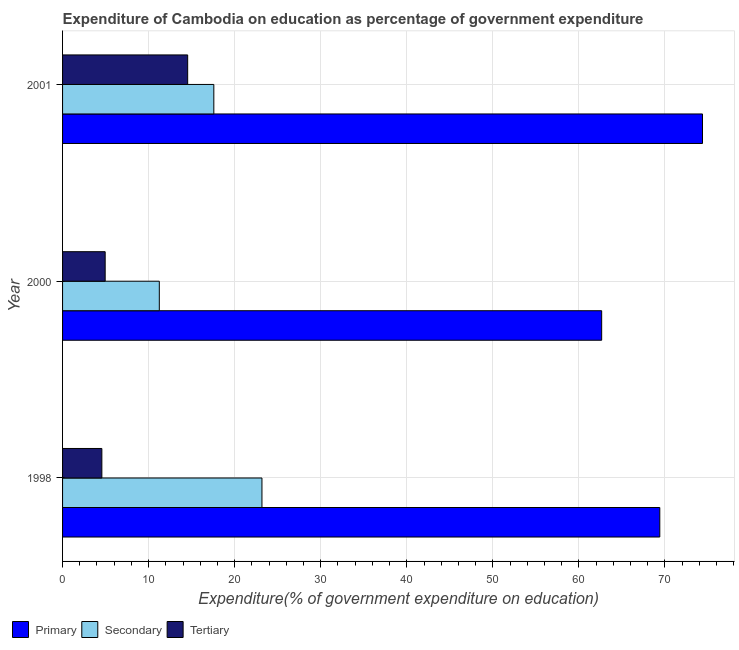Are the number of bars per tick equal to the number of legend labels?
Your answer should be compact. Yes. Are the number of bars on each tick of the Y-axis equal?
Offer a very short reply. Yes. How many bars are there on the 1st tick from the bottom?
Provide a succinct answer. 3. What is the label of the 3rd group of bars from the top?
Offer a very short reply. 1998. In how many cases, is the number of bars for a given year not equal to the number of legend labels?
Your answer should be compact. 0. What is the expenditure on primary education in 1998?
Ensure brevity in your answer.  69.4. Across all years, what is the maximum expenditure on primary education?
Your answer should be compact. 74.36. Across all years, what is the minimum expenditure on tertiary education?
Give a very brief answer. 4.57. What is the total expenditure on secondary education in the graph?
Your answer should be very brief. 51.99. What is the difference between the expenditure on secondary education in 1998 and that in 2001?
Make the answer very short. 5.59. What is the difference between the expenditure on primary education in 2000 and the expenditure on secondary education in 1998?
Your answer should be compact. 39.48. What is the average expenditure on primary education per year?
Provide a succinct answer. 68.8. In the year 2000, what is the difference between the expenditure on tertiary education and expenditure on secondary education?
Your answer should be compact. -6.29. What is the ratio of the expenditure on primary education in 1998 to that in 2001?
Ensure brevity in your answer.  0.93. Is the expenditure on primary education in 1998 less than that in 2000?
Your answer should be compact. No. What is the difference between the highest and the second highest expenditure on primary education?
Provide a short and direct response. 4.96. What is the difference between the highest and the lowest expenditure on primary education?
Provide a short and direct response. 11.72. In how many years, is the expenditure on primary education greater than the average expenditure on primary education taken over all years?
Ensure brevity in your answer.  2. What does the 3rd bar from the top in 2001 represents?
Offer a terse response. Primary. What does the 1st bar from the bottom in 2000 represents?
Provide a short and direct response. Primary. How many bars are there?
Provide a succinct answer. 9. Does the graph contain any zero values?
Your response must be concise. No. Does the graph contain grids?
Ensure brevity in your answer.  Yes. How many legend labels are there?
Your answer should be compact. 3. What is the title of the graph?
Keep it short and to the point. Expenditure of Cambodia on education as percentage of government expenditure. Does "Czech Republic" appear as one of the legend labels in the graph?
Offer a terse response. No. What is the label or title of the X-axis?
Ensure brevity in your answer.  Expenditure(% of government expenditure on education). What is the Expenditure(% of government expenditure on education) in Primary in 1998?
Your answer should be very brief. 69.4. What is the Expenditure(% of government expenditure on education) in Secondary in 1998?
Your answer should be compact. 23.17. What is the Expenditure(% of government expenditure on education) in Tertiary in 1998?
Make the answer very short. 4.57. What is the Expenditure(% of government expenditure on education) in Primary in 2000?
Ensure brevity in your answer.  62.65. What is the Expenditure(% of government expenditure on education) of Secondary in 2000?
Your response must be concise. 11.24. What is the Expenditure(% of government expenditure on education) in Tertiary in 2000?
Ensure brevity in your answer.  4.95. What is the Expenditure(% of government expenditure on education) of Primary in 2001?
Ensure brevity in your answer.  74.36. What is the Expenditure(% of government expenditure on education) in Secondary in 2001?
Make the answer very short. 17.58. What is the Expenditure(% of government expenditure on education) in Tertiary in 2001?
Offer a terse response. 14.54. Across all years, what is the maximum Expenditure(% of government expenditure on education) in Primary?
Provide a succinct answer. 74.36. Across all years, what is the maximum Expenditure(% of government expenditure on education) of Secondary?
Your answer should be compact. 23.17. Across all years, what is the maximum Expenditure(% of government expenditure on education) of Tertiary?
Your answer should be compact. 14.54. Across all years, what is the minimum Expenditure(% of government expenditure on education) of Primary?
Ensure brevity in your answer.  62.65. Across all years, what is the minimum Expenditure(% of government expenditure on education) in Secondary?
Offer a terse response. 11.24. Across all years, what is the minimum Expenditure(% of government expenditure on education) in Tertiary?
Ensure brevity in your answer.  4.57. What is the total Expenditure(% of government expenditure on education) in Primary in the graph?
Keep it short and to the point. 206.41. What is the total Expenditure(% of government expenditure on education) of Secondary in the graph?
Offer a very short reply. 51.99. What is the total Expenditure(% of government expenditure on education) of Tertiary in the graph?
Provide a succinct answer. 24.05. What is the difference between the Expenditure(% of government expenditure on education) in Primary in 1998 and that in 2000?
Provide a short and direct response. 6.76. What is the difference between the Expenditure(% of government expenditure on education) in Secondary in 1998 and that in 2000?
Offer a terse response. 11.93. What is the difference between the Expenditure(% of government expenditure on education) of Tertiary in 1998 and that in 2000?
Your response must be concise. -0.39. What is the difference between the Expenditure(% of government expenditure on education) in Primary in 1998 and that in 2001?
Provide a short and direct response. -4.96. What is the difference between the Expenditure(% of government expenditure on education) in Secondary in 1998 and that in 2001?
Offer a terse response. 5.59. What is the difference between the Expenditure(% of government expenditure on education) in Tertiary in 1998 and that in 2001?
Your answer should be very brief. -9.97. What is the difference between the Expenditure(% of government expenditure on education) of Primary in 2000 and that in 2001?
Provide a short and direct response. -11.72. What is the difference between the Expenditure(% of government expenditure on education) in Secondary in 2000 and that in 2001?
Offer a very short reply. -6.34. What is the difference between the Expenditure(% of government expenditure on education) in Tertiary in 2000 and that in 2001?
Offer a very short reply. -9.59. What is the difference between the Expenditure(% of government expenditure on education) of Primary in 1998 and the Expenditure(% of government expenditure on education) of Secondary in 2000?
Your answer should be very brief. 58.16. What is the difference between the Expenditure(% of government expenditure on education) of Primary in 1998 and the Expenditure(% of government expenditure on education) of Tertiary in 2000?
Make the answer very short. 64.45. What is the difference between the Expenditure(% of government expenditure on education) in Secondary in 1998 and the Expenditure(% of government expenditure on education) in Tertiary in 2000?
Offer a very short reply. 18.22. What is the difference between the Expenditure(% of government expenditure on education) in Primary in 1998 and the Expenditure(% of government expenditure on education) in Secondary in 2001?
Provide a succinct answer. 51.82. What is the difference between the Expenditure(% of government expenditure on education) in Primary in 1998 and the Expenditure(% of government expenditure on education) in Tertiary in 2001?
Make the answer very short. 54.86. What is the difference between the Expenditure(% of government expenditure on education) of Secondary in 1998 and the Expenditure(% of government expenditure on education) of Tertiary in 2001?
Offer a very short reply. 8.63. What is the difference between the Expenditure(% of government expenditure on education) of Primary in 2000 and the Expenditure(% of government expenditure on education) of Secondary in 2001?
Give a very brief answer. 45.07. What is the difference between the Expenditure(% of government expenditure on education) in Primary in 2000 and the Expenditure(% of government expenditure on education) in Tertiary in 2001?
Keep it short and to the point. 48.11. What is the difference between the Expenditure(% of government expenditure on education) of Secondary in 2000 and the Expenditure(% of government expenditure on education) of Tertiary in 2001?
Give a very brief answer. -3.29. What is the average Expenditure(% of government expenditure on education) in Primary per year?
Your response must be concise. 68.8. What is the average Expenditure(% of government expenditure on education) of Secondary per year?
Your response must be concise. 17.33. What is the average Expenditure(% of government expenditure on education) of Tertiary per year?
Offer a very short reply. 8.02. In the year 1998, what is the difference between the Expenditure(% of government expenditure on education) in Primary and Expenditure(% of government expenditure on education) in Secondary?
Provide a short and direct response. 46.23. In the year 1998, what is the difference between the Expenditure(% of government expenditure on education) of Primary and Expenditure(% of government expenditure on education) of Tertiary?
Ensure brevity in your answer.  64.84. In the year 1998, what is the difference between the Expenditure(% of government expenditure on education) in Secondary and Expenditure(% of government expenditure on education) in Tertiary?
Keep it short and to the point. 18.6. In the year 2000, what is the difference between the Expenditure(% of government expenditure on education) of Primary and Expenditure(% of government expenditure on education) of Secondary?
Offer a very short reply. 51.4. In the year 2000, what is the difference between the Expenditure(% of government expenditure on education) in Primary and Expenditure(% of government expenditure on education) in Tertiary?
Your answer should be compact. 57.7. In the year 2000, what is the difference between the Expenditure(% of government expenditure on education) in Secondary and Expenditure(% of government expenditure on education) in Tertiary?
Your answer should be very brief. 6.29. In the year 2001, what is the difference between the Expenditure(% of government expenditure on education) in Primary and Expenditure(% of government expenditure on education) in Secondary?
Offer a very short reply. 56.78. In the year 2001, what is the difference between the Expenditure(% of government expenditure on education) in Primary and Expenditure(% of government expenditure on education) in Tertiary?
Provide a short and direct response. 59.83. In the year 2001, what is the difference between the Expenditure(% of government expenditure on education) in Secondary and Expenditure(% of government expenditure on education) in Tertiary?
Ensure brevity in your answer.  3.04. What is the ratio of the Expenditure(% of government expenditure on education) in Primary in 1998 to that in 2000?
Give a very brief answer. 1.11. What is the ratio of the Expenditure(% of government expenditure on education) in Secondary in 1998 to that in 2000?
Provide a succinct answer. 2.06. What is the ratio of the Expenditure(% of government expenditure on education) in Tertiary in 1998 to that in 2000?
Provide a succinct answer. 0.92. What is the ratio of the Expenditure(% of government expenditure on education) of Secondary in 1998 to that in 2001?
Give a very brief answer. 1.32. What is the ratio of the Expenditure(% of government expenditure on education) of Tertiary in 1998 to that in 2001?
Offer a very short reply. 0.31. What is the ratio of the Expenditure(% of government expenditure on education) of Primary in 2000 to that in 2001?
Offer a very short reply. 0.84. What is the ratio of the Expenditure(% of government expenditure on education) in Secondary in 2000 to that in 2001?
Give a very brief answer. 0.64. What is the ratio of the Expenditure(% of government expenditure on education) of Tertiary in 2000 to that in 2001?
Provide a short and direct response. 0.34. What is the difference between the highest and the second highest Expenditure(% of government expenditure on education) in Primary?
Make the answer very short. 4.96. What is the difference between the highest and the second highest Expenditure(% of government expenditure on education) in Secondary?
Ensure brevity in your answer.  5.59. What is the difference between the highest and the second highest Expenditure(% of government expenditure on education) of Tertiary?
Provide a short and direct response. 9.59. What is the difference between the highest and the lowest Expenditure(% of government expenditure on education) in Primary?
Offer a very short reply. 11.72. What is the difference between the highest and the lowest Expenditure(% of government expenditure on education) in Secondary?
Give a very brief answer. 11.93. What is the difference between the highest and the lowest Expenditure(% of government expenditure on education) in Tertiary?
Ensure brevity in your answer.  9.97. 